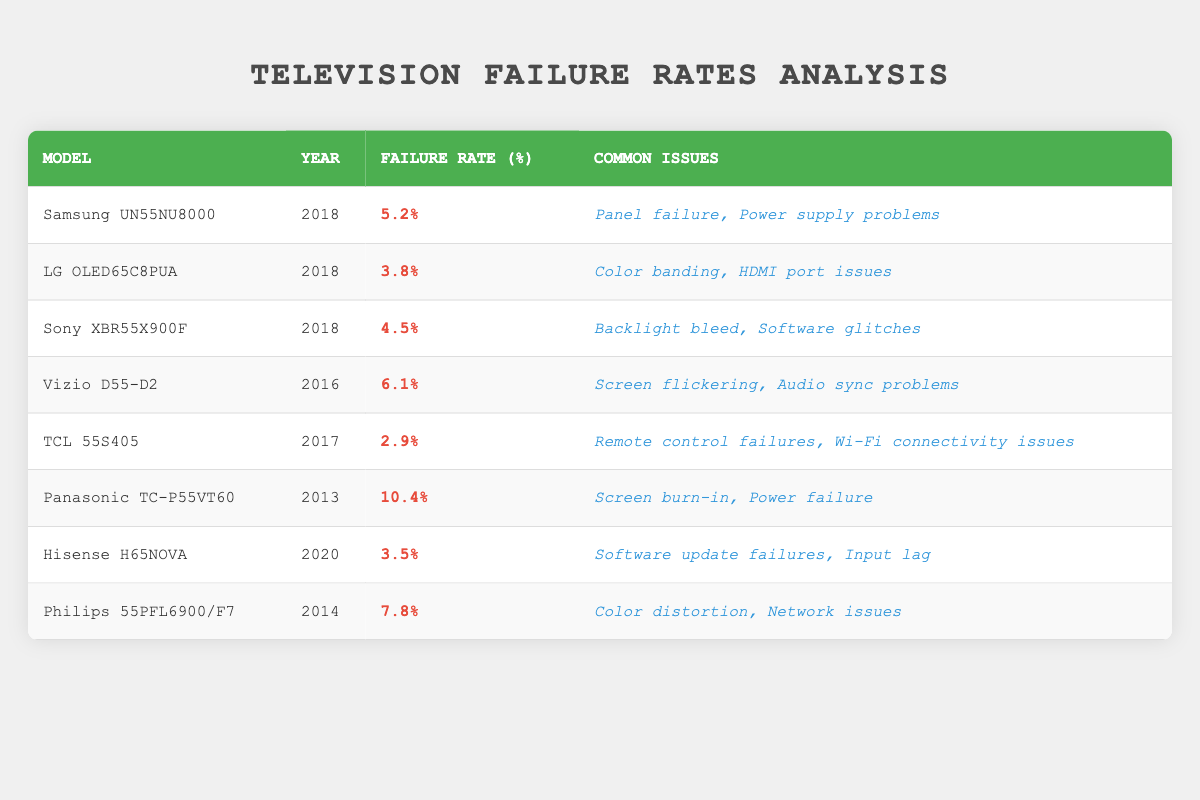What is the failure rate of the Samsung UN55NU8000? The failure rate for the Samsung UN55NU8000, as listed in the table, is 5.2%.
Answer: 5.2% Which model has the highest failure rate? By comparing the failure rates in the table, the Panasonic TC-P55VT60 has the highest failure rate at 10.4%.
Answer: Panasonic TC-P55VT60 Is the failure rate of the LG OLED65C8PUA lower than 5%? The failure rate of the LG OLED65C8PUA is 3.8%, which is lower than 5%. Therefore, the statement is true.
Answer: Yes What is the median failure rate among all the models? To find the median, list the failure rates in ascending order: 2.9%, 3.5%, 3.8%, 4.5%, 5.2%, 6.1%, 7.8%, 10.4%. There are 8 values, so the median is the average of the 4th and 5th values: (4.5 + 5.2) / 2 = 4.85%.
Answer: 4.85% Does the Hisense H65NOVA have a higher failure rate than the TCL 55S405? The failure rate of Hisense H65NOVA is 3.5%, while the TCL 55S405 has a rate of 2.9%. Since 3.5% is greater than 2.9%, the answer is yes.
Answer: Yes Which two models from 2018 have failure rates higher than 4%? The models from 2018 are Samsung UN55NU8000 (5.2%), LG OLED65C8PUA (3.8%), and Sony XBR55X900F (4.5%). The Samsung and Sony models have rates above 4%.
Answer: Samsung UN55NU8000, Sony XBR55X900F What is the total failure rate percentage of all models listed? The total failure rate is calculated by summing all the individual failure rates: 5.2 + 3.8 + 4.5 + 6.1 + 2.9 + 10.4 + 3.5 + 7.8 = 44.2%.
Answer: 44.2% Are there any models that report "Power supply problems" as a common issue? Looking through the table, the Samsung UN55NU8000 and the Panasonic TC-P55VT60 both list "Power supply problems" as common issues, confirming that such models exist.
Answer: Yes 